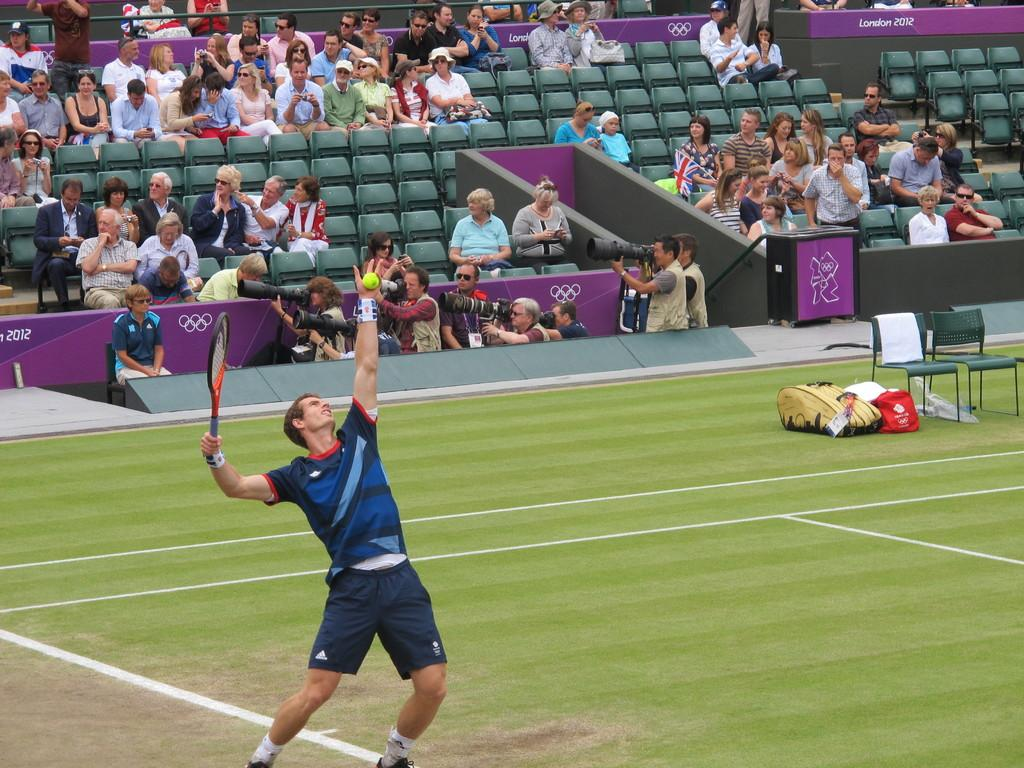<image>
Render a clear and concise summary of the photo. A tennis player at an arena labeled London 2012. 